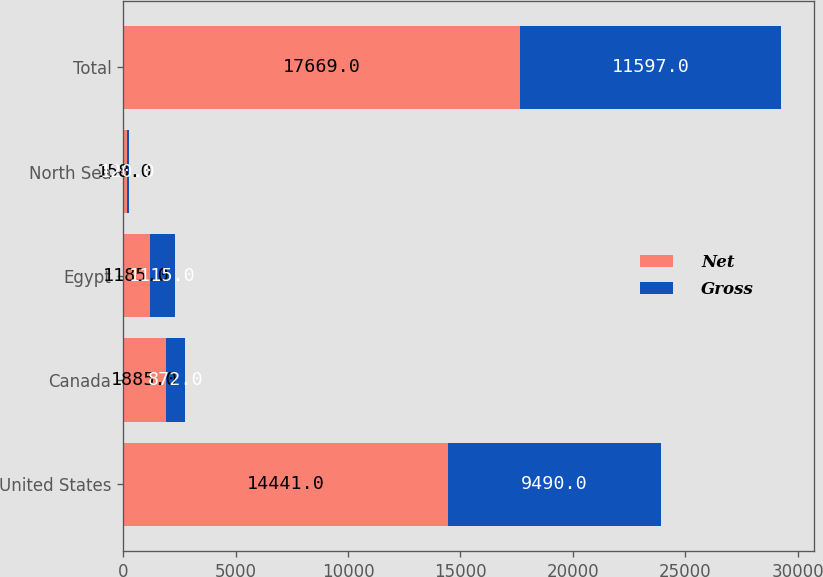<chart> <loc_0><loc_0><loc_500><loc_500><stacked_bar_chart><ecel><fcel>United States<fcel>Canada<fcel>Egypt<fcel>North Sea<fcel>Total<nl><fcel>Net<fcel>14441<fcel>1885<fcel>1185<fcel>158<fcel>17669<nl><fcel>Gross<fcel>9490<fcel>872<fcel>1115<fcel>120<fcel>11597<nl></chart> 